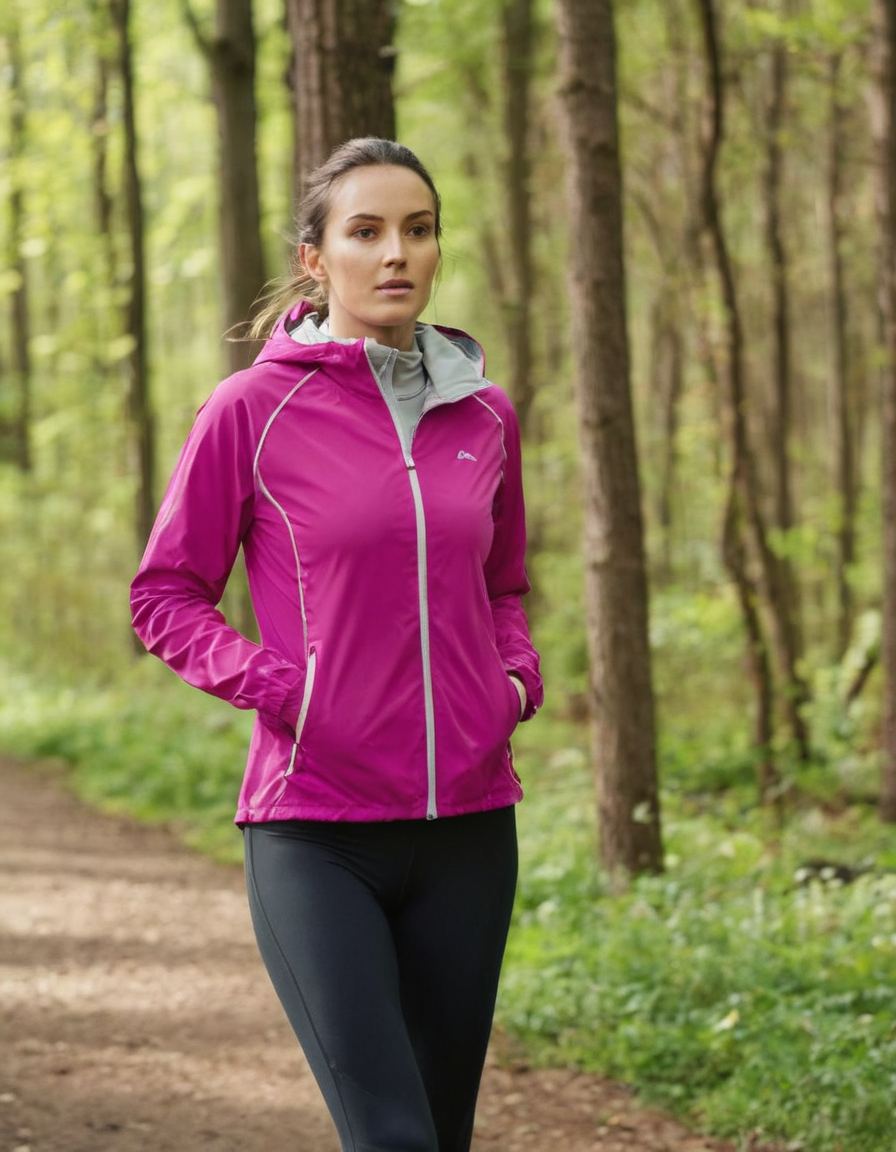Is the following image artificially (AI) generated? Explain your reasoning. No, this image does not appear to be artificially generated by AI. It is a real photograph capturing a woman wearing athletic clothing while standing on a trail in a forest or wooded area.

The details in the image, such as the textures of the trees, the focus on the woman's facial features and outfit, and the natural lighting and depth of field, all suggest this is a genuine photograph taken with a camera rather than an AI-generated image. AI-generated images often have artifacts, inconsistencies, or unnatural elements that reveal their artificial origins, but this image looks photorealistic without any obvious flaws or anomalies that would indicate it was generated by an AI model. 